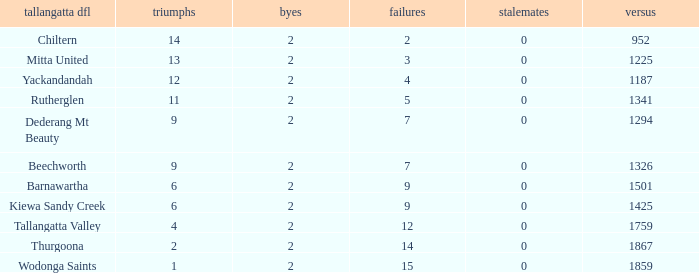What are the draws when wins are fwewer than 9 and byes fewer than 2? 0.0. 